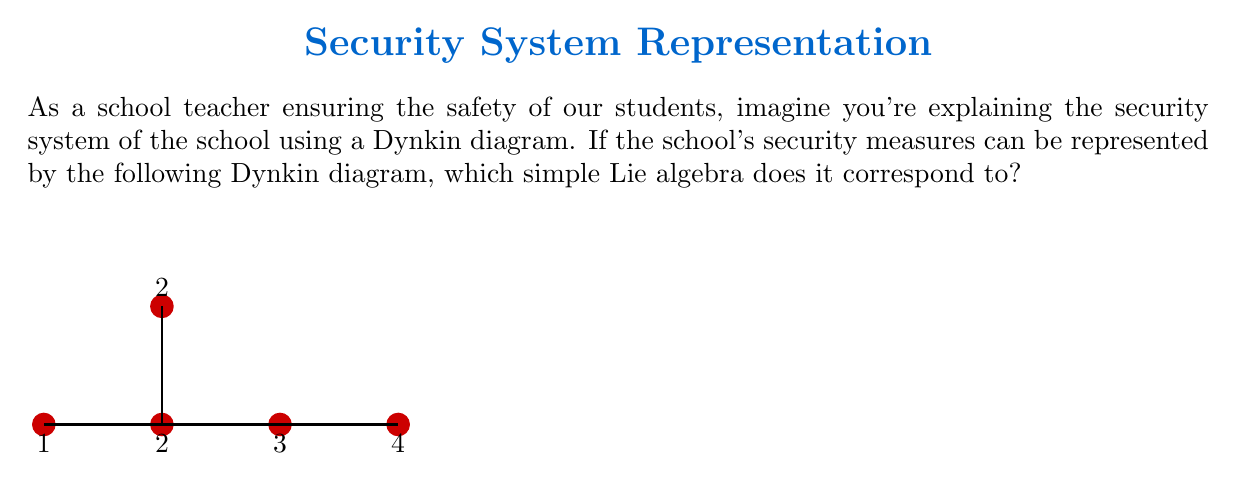Teach me how to tackle this problem. To classify this simple Lie algebra using its Dynkin diagram, we follow these steps:

1) First, we identify the key features of the diagram:
   - It has 5 nodes in total
   - There's a branch point (node with 3 connections)
   - The longest chain has 4 nodes

2) These characteristics match the Dynkin diagram of type $D_5$.

3) In general, $D_n$ Dynkin diagrams (for $n \geq 4$) have the following properties:
   - $n$ nodes in total
   - A branch point at the third-to-last node
   - Two short branches of length 1 at the end

4) Our diagram fits this pattern with $n=5$.

5) The $D_5$ Lie algebra corresponds to the special orthogonal Lie algebra $\mathfrak{so}(10)$.

6) In terms of the school security analogy:
   - Each node could represent a security measure (e.g., cameras, locks, guards, alarms)
   - The connections show how these measures interact
   - The branching point might represent a central security office coordinating different aspects

Therefore, this Dynkin diagram represents the $D_5$ simple Lie algebra, which is isomorphic to $\mathfrak{so}(10)$.
Answer: $D_5$ or $\mathfrak{so}(10)$ 